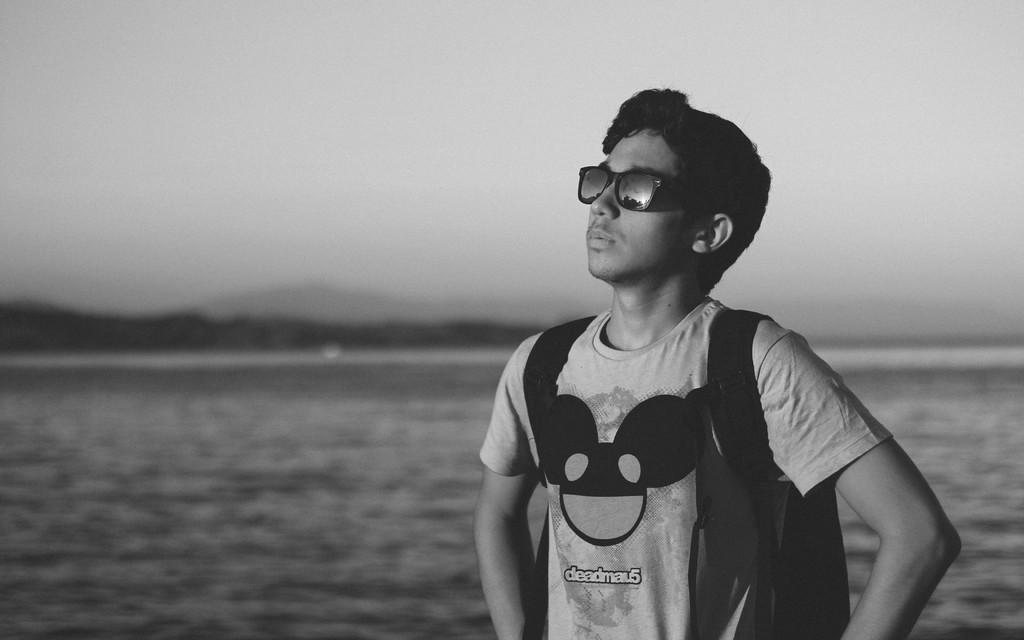Who or what is the main subject of the image? There is a person in the image. What can be seen in the background of the image? The background of the image includes water. What else is visible in the background of the image? The sky is visible in the background of the image. How is the image presented in terms of color? The image is in black and white. What type of bun is being used to spell out a word in the image? There is no bun or word present in the image; it only features a person in a black and white setting with water and sky in the background. 